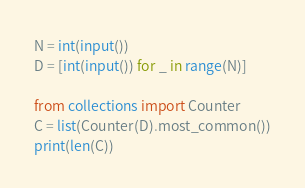<code> <loc_0><loc_0><loc_500><loc_500><_Python_>N = int(input())
D = [int(input()) for _ in range(N)]

from collections import Counter
C = list(Counter(D).most_common())
print(len(C))</code> 